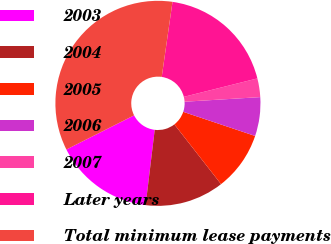Convert chart to OTSL. <chart><loc_0><loc_0><loc_500><loc_500><pie_chart><fcel>2003<fcel>2004<fcel>2005<fcel>2006<fcel>2007<fcel>Later years<fcel>Total minimum lease payments<nl><fcel>15.65%<fcel>12.47%<fcel>9.29%<fcel>6.12%<fcel>2.94%<fcel>18.82%<fcel>34.7%<nl></chart> 